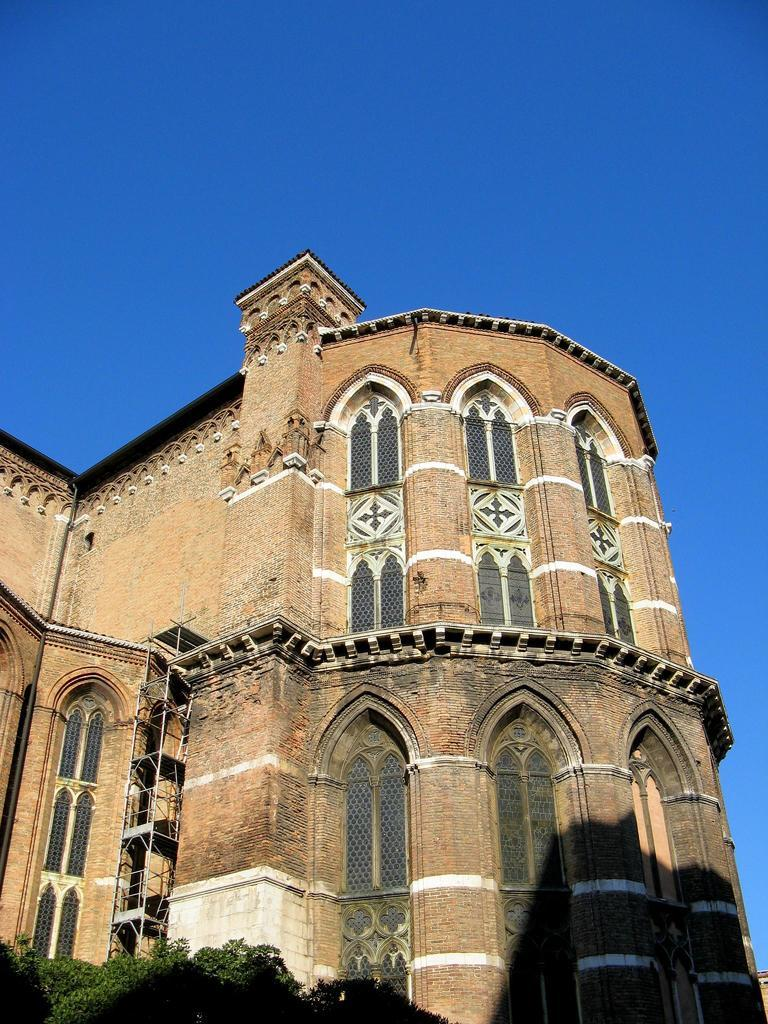What type of structure is present in the image? There is a building in the image. What else can be seen in the image besides the building? There are plants in the image. What can be seen in the background of the image? The sky is visible in the background of the image. How many letters are being passed around in the crowd in the image? There is no crowd or letters present in the image; it features a building and plants. 